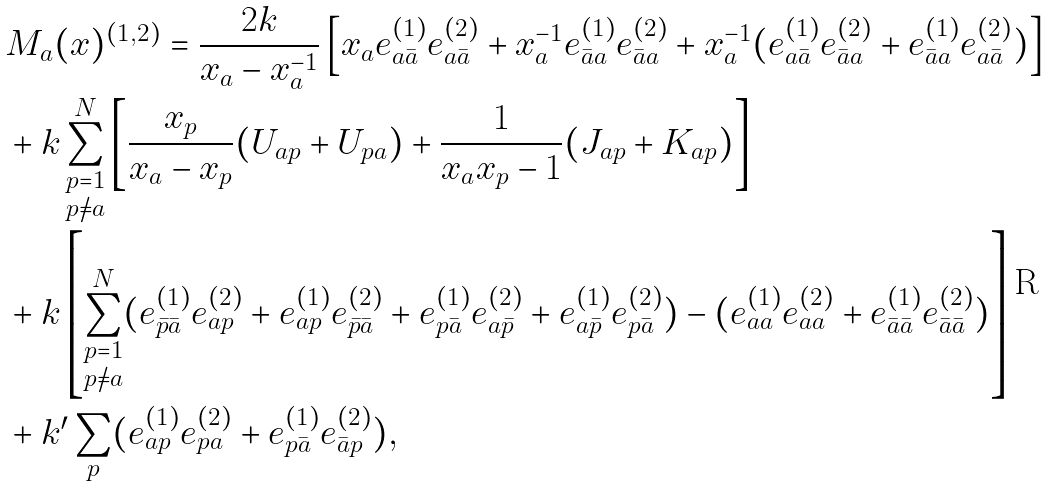<formula> <loc_0><loc_0><loc_500><loc_500>& M _ { a } ( x ) ^ { ( 1 , 2 ) } = \frac { 2 k } { x _ { a } - x _ { a } ^ { - 1 } } \left [ x _ { a } e _ { a \bar { a } } ^ { ( 1 ) } e _ { a \bar { a } } ^ { ( 2 ) } + x _ { a } ^ { - 1 } e _ { \bar { a } a } ^ { ( 1 ) } e _ { \bar { a } a } ^ { ( 2 ) } + x _ { a } ^ { - 1 } ( e _ { a \bar { a } } ^ { ( 1 ) } e _ { \bar { a } a } ^ { ( 2 ) } + e _ { \bar { a } a } ^ { ( 1 ) } e _ { a \bar { a } } ^ { ( 2 ) } ) \right ] \\ & + k \sum _ { \begin{subarray} { c } p = 1 \\ p \not = a \end{subarray} } ^ { N } \left [ \frac { x _ { p } } { x _ { a } - x _ { p } } ( U _ { a p } + U _ { p a } ) + \frac { 1 } { x _ { a } x _ { p } - 1 } ( J _ { a p } + K _ { a p } ) \right ] \\ & + k \left [ \sum _ { \begin{subarray} { c } p = 1 \\ p \not = a \end{subarray} } ^ { N } ( e _ { \bar { p } \bar { a } } ^ { ( 1 ) } e _ { a p } ^ { ( 2 ) } + e _ { a p } ^ { ( 1 ) } e _ { \bar { p } \bar { a } } ^ { ( 2 ) } + e _ { p \bar { a } } ^ { ( 1 ) } e _ { a \bar { p } } ^ { ( 2 ) } + e _ { a \bar { p } } ^ { ( 1 ) } e _ { p \bar { a } } ^ { ( 2 ) } ) - ( e _ { a a } ^ { ( 1 ) } e _ { a a } ^ { ( 2 ) } + e _ { \bar { a } \bar { a } } ^ { ( 1 ) } e _ { \bar { a } \bar { a } } ^ { ( 2 ) } ) \right ] \\ & + k { ^ { \prime } } \sum _ { p } ( e _ { a p } ^ { ( 1 ) } e _ { p a } ^ { ( 2 ) } + e _ { p \bar { a } } ^ { ( 1 ) } e _ { \bar { a } p } ^ { ( 2 ) } ) ,</formula> 